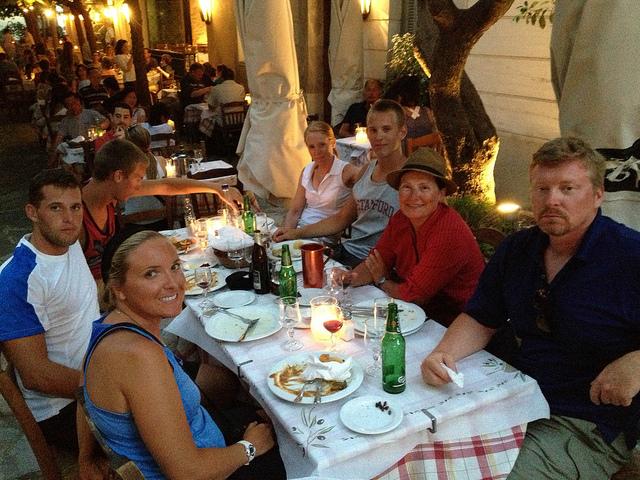What is the primary source of ambient lighting?
Be succinct. Candles. What is in the green bottles?
Short answer required. Beer. Are all the people looking at the camera?
Answer briefly. No. 